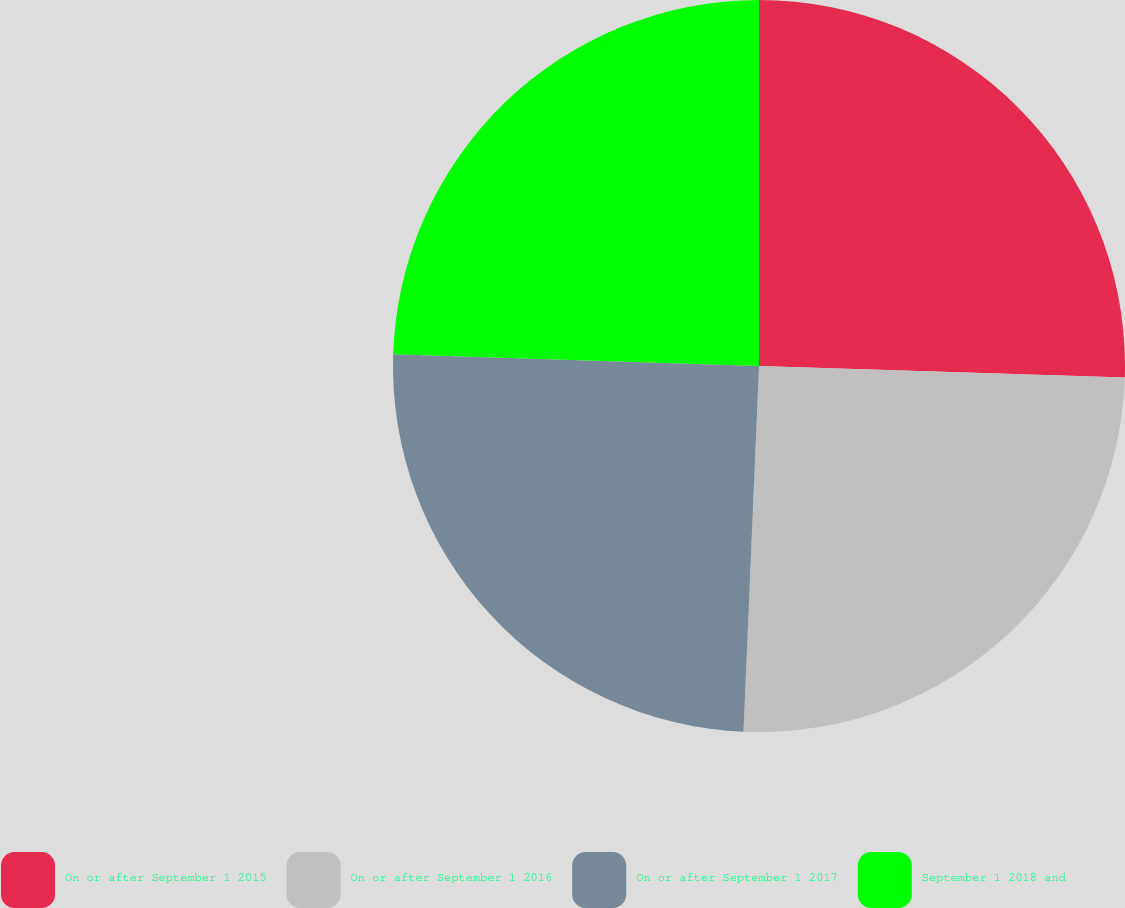Convert chart to OTSL. <chart><loc_0><loc_0><loc_500><loc_500><pie_chart><fcel>On or after September 1 2015<fcel>On or after September 1 2016<fcel>On or after September 1 2017<fcel>September 1 2018 and<nl><fcel>25.5%<fcel>25.17%<fcel>24.83%<fcel>24.49%<nl></chart> 